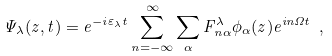Convert formula to latex. <formula><loc_0><loc_0><loc_500><loc_500>\Psi _ { \lambda } ( z , t ) = e ^ { - i \varepsilon _ { \lambda } t } \sum _ { n = - \infty } ^ { \infty } \sum _ { \alpha } F _ { n \alpha } ^ { \lambda } \phi _ { \alpha } ( z ) e ^ { i n \Omega t } \ ,</formula> 